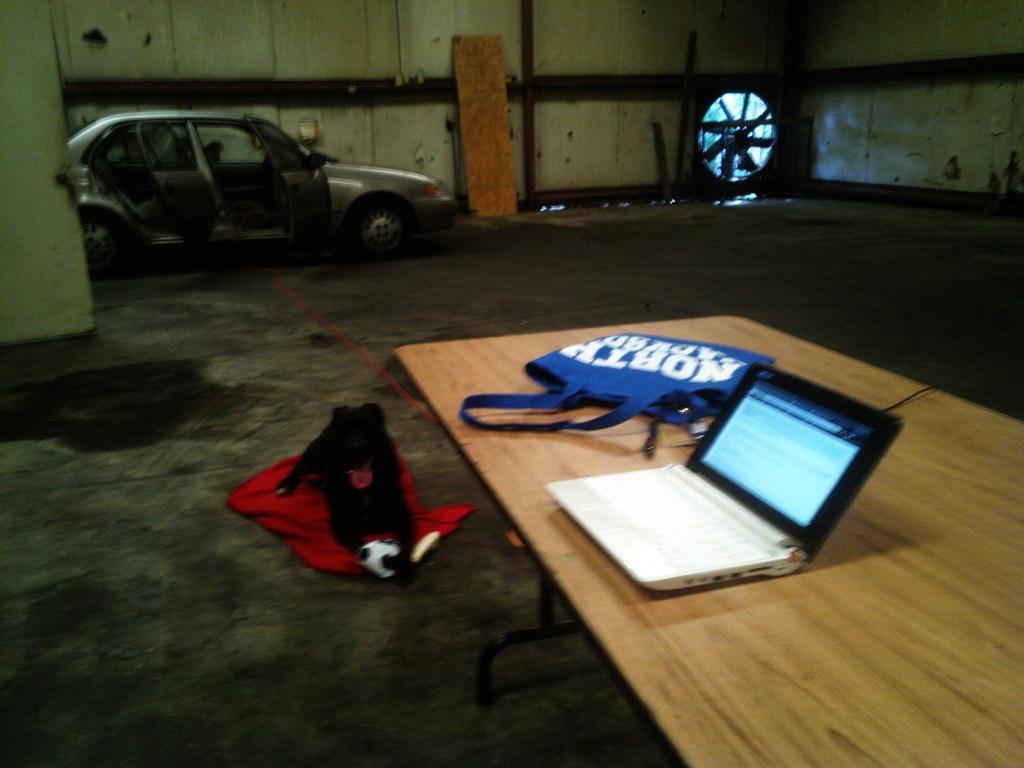How would you summarize this image in a sentence or two? As we can see in the image, there is a car, a table and on table there is a laptop and blue color bag. On floor there is a black color dog. 